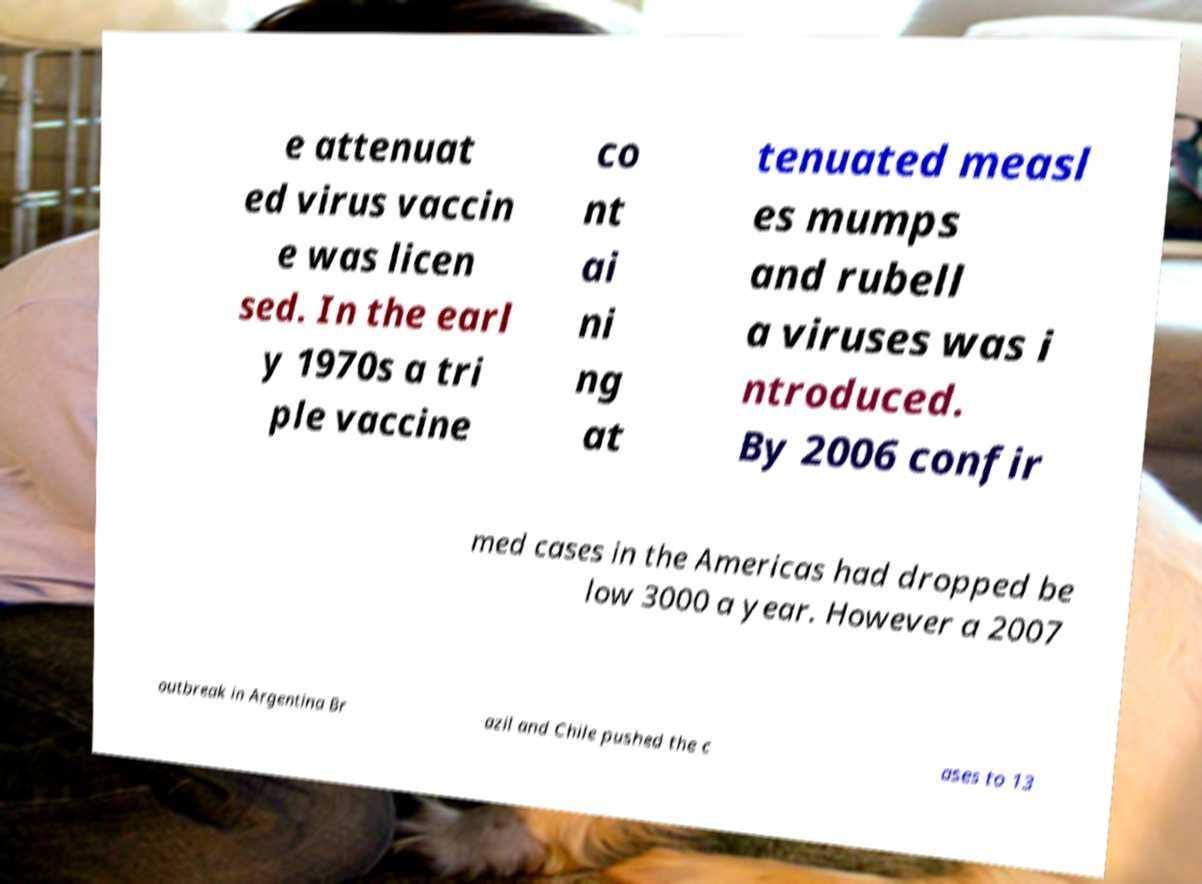I need the written content from this picture converted into text. Can you do that? e attenuat ed virus vaccin e was licen sed. In the earl y 1970s a tri ple vaccine co nt ai ni ng at tenuated measl es mumps and rubell a viruses was i ntroduced. By 2006 confir med cases in the Americas had dropped be low 3000 a year. However a 2007 outbreak in Argentina Br azil and Chile pushed the c ases to 13 